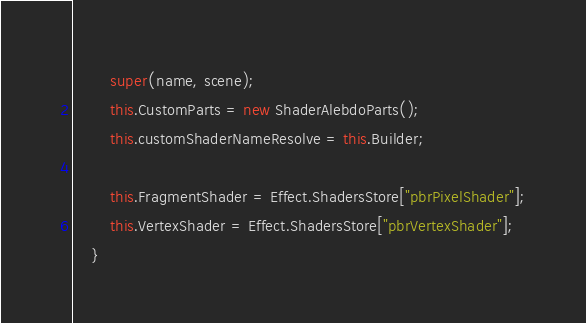Convert code to text. <code><loc_0><loc_0><loc_500><loc_500><_TypeScript_>        super(name, scene);
        this.CustomParts = new ShaderAlebdoParts();
        this.customShaderNameResolve = this.Builder;

        this.FragmentShader = Effect.ShadersStore["pbrPixelShader"];
        this.VertexShader = Effect.ShadersStore["pbrVertexShader"];
    }
</code> 